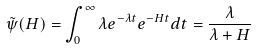Convert formula to latex. <formula><loc_0><loc_0><loc_500><loc_500>\tilde { \psi } ( H ) = \int _ { 0 } ^ { \infty } \lambda e ^ { - \lambda t } e ^ { - H t } d t = \frac { \lambda } { \lambda + H }</formula> 